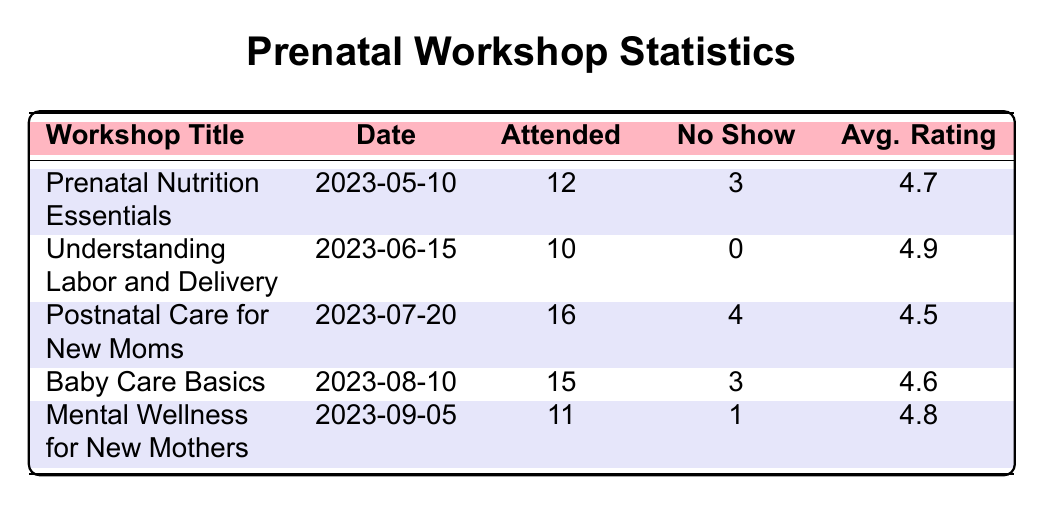What is the highest average rating among the workshops? The table shows the average ratings for each workshop. Comparing the ratings: 4.7, 4.9, 4.5, 4.6, and 4.8, the highest rating is 4.9 for the "Understanding Labor and Delivery" workshop.
Answer: 4.9 How many participants attended the "Postnatal Care for New Moms" workshop? The table lists that 16 participants attended the "Postnatal Care for New Moms" workshop.
Answer: 16 What is the total number of no-shows across all workshops? Adding the no-show values from the table: 3 (Prenatal Nutrition Essentials) + 0 (Understanding Labor and Delivery) + 4 (Postnatal Care for New Moms) + 3 (Baby Care Basics) + 1 (Mental Wellness for New Mothers) gives 3 + 0 + 4 + 3 + 1 = 11.
Answer: 11 Did any workshop have a zero no-show rate? The data for the "Understanding Labor and Delivery" workshop indicates a no-show rate of 0. Thus, this workshop had zero no-shows.
Answer: Yes What is the average rating of the "Baby Care Basics" and "Mental Wellness for New Mothers" workshops combined? The average ratings are 4.6 for "Baby Care Basics" and 4.8 for "Mental Wellness for New Mothers." The sum is 4.6 + 4.8 = 9.4. Dividing by the number of workshops (2) gives 9.4 / 2 = 4.7.
Answer: 4.7 How many workshops had more attendees than no-shows? Checking each workshop: "Prenatal Nutrition Essentials" (12 attended, 3 no-shows), "Understanding Labor and Delivery" (10 attended, 0 no-shows), "Postnatal Care for New Moms" (16 attended, 4 no-shows), "Baby Care Basics" (15 attended, 3 no-shows), "Mental Wellness for New Mothers" (11 attended, 1 no-show). All had more attendees than no-shows, resulting in a total of 5 workshops.
Answer: 5 What was the attendance rate (percentage) for the "Prenatal Nutrition Essentials" workshop? The attendance rate is calculated by the formula: (attended/total participants) * 100. For "Prenatal Nutrition Essentials", it is (12/15) * 100 = 80%.
Answer: 80% Which workshop had the least attendance? Comparing attendance figures: 12, 10, 16, 15, and 11 shows that "Understanding Labor and Delivery" had the least attendance with 10 participants.
Answer: "Understanding Labor and Delivery" 